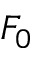Convert formula to latex. <formula><loc_0><loc_0><loc_500><loc_500>F _ { 0 }</formula> 